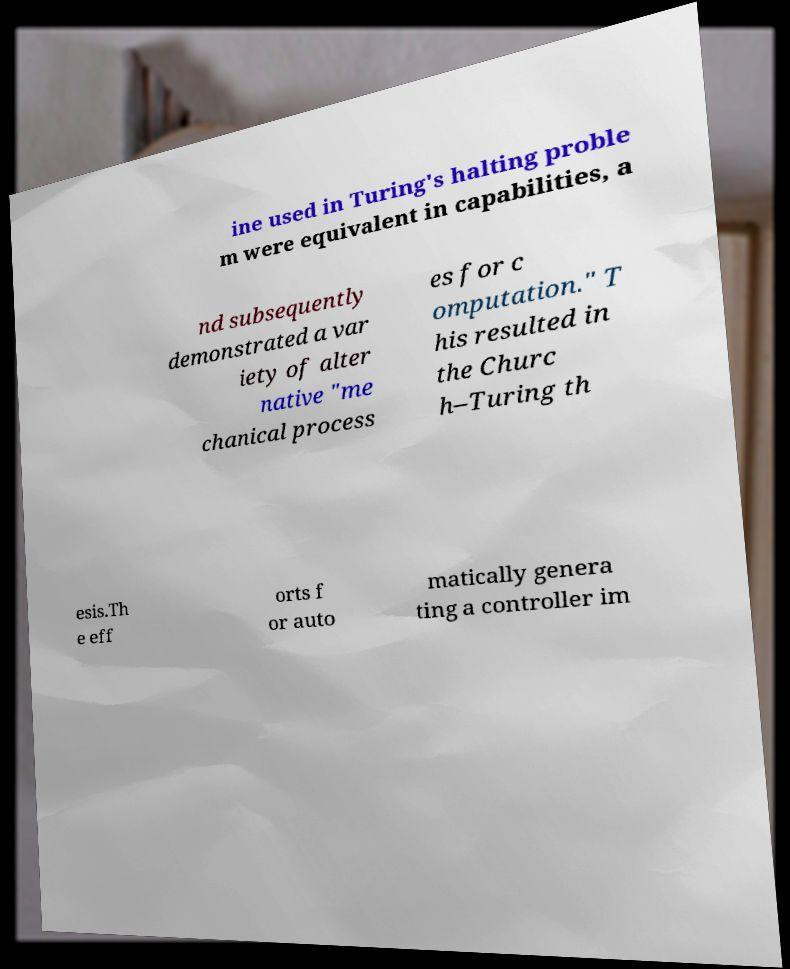Could you extract and type out the text from this image? ine used in Turing's halting proble m were equivalent in capabilities, a nd subsequently demonstrated a var iety of alter native "me chanical process es for c omputation." T his resulted in the Churc h–Turing th esis.Th e eff orts f or auto matically genera ting a controller im 